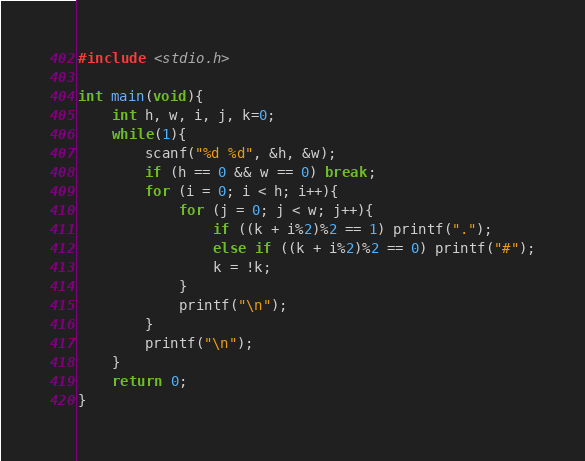Convert code to text. <code><loc_0><loc_0><loc_500><loc_500><_C_>#include <stdio.h>

int main(void){
	int h, w, i, j, k=0;
	while(1){
		scanf("%d %d", &h, &w);
		if (h == 0 && w == 0) break;
		for (i = 0; i < h; i++){
			for (j = 0; j < w; j++){
				if ((k + i%2)%2 == 1) printf(".");
				else if ((k + i%2)%2 == 0) printf("#");
				k = !k;
			}
			printf("\n");
		}
		printf("\n");
	}
	return 0;
}</code> 